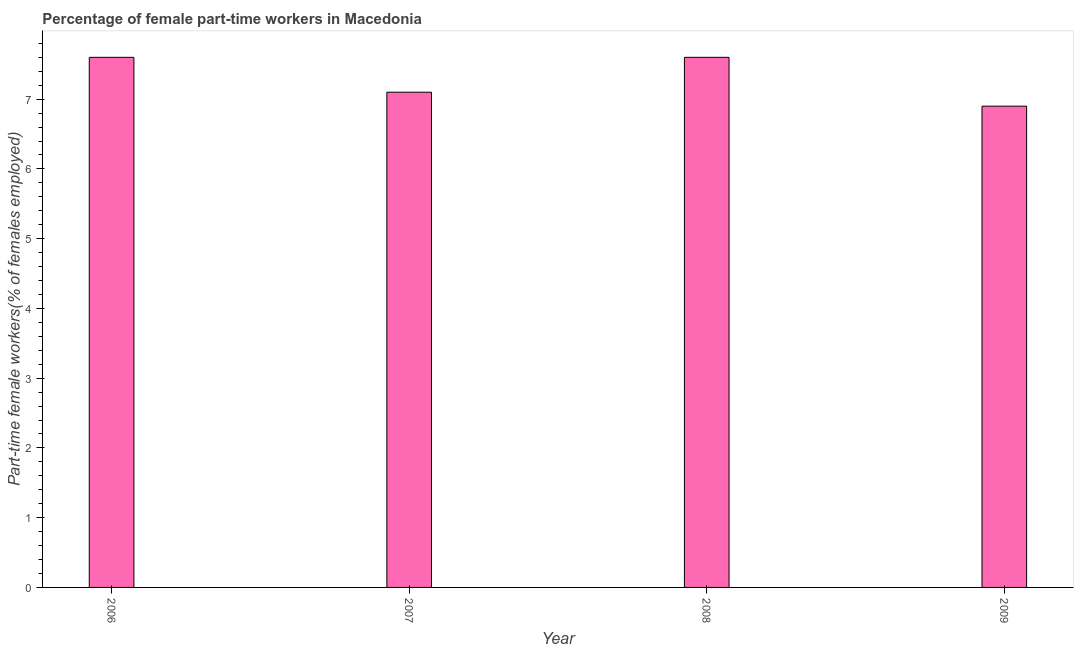Does the graph contain grids?
Your answer should be compact. No. What is the title of the graph?
Give a very brief answer. Percentage of female part-time workers in Macedonia. What is the label or title of the X-axis?
Your response must be concise. Year. What is the label or title of the Y-axis?
Keep it short and to the point. Part-time female workers(% of females employed). What is the percentage of part-time female workers in 2009?
Ensure brevity in your answer.  6.9. Across all years, what is the maximum percentage of part-time female workers?
Your answer should be compact. 7.6. Across all years, what is the minimum percentage of part-time female workers?
Your response must be concise. 6.9. In which year was the percentage of part-time female workers maximum?
Offer a terse response. 2006. What is the sum of the percentage of part-time female workers?
Keep it short and to the point. 29.2. What is the difference between the percentage of part-time female workers in 2007 and 2008?
Ensure brevity in your answer.  -0.5. What is the median percentage of part-time female workers?
Offer a terse response. 7.35. In how many years, is the percentage of part-time female workers greater than 4.6 %?
Provide a short and direct response. 4. What is the ratio of the percentage of part-time female workers in 2006 to that in 2009?
Give a very brief answer. 1.1. Is the percentage of part-time female workers in 2008 less than that in 2009?
Keep it short and to the point. No. Is the difference between the percentage of part-time female workers in 2007 and 2008 greater than the difference between any two years?
Offer a very short reply. No. What is the difference between the highest and the second highest percentage of part-time female workers?
Your response must be concise. 0. Is the sum of the percentage of part-time female workers in 2007 and 2008 greater than the maximum percentage of part-time female workers across all years?
Offer a terse response. Yes. How many bars are there?
Offer a very short reply. 4. How many years are there in the graph?
Your answer should be very brief. 4. What is the Part-time female workers(% of females employed) in 2006?
Your answer should be very brief. 7.6. What is the Part-time female workers(% of females employed) of 2007?
Make the answer very short. 7.1. What is the Part-time female workers(% of females employed) in 2008?
Your response must be concise. 7.6. What is the Part-time female workers(% of females employed) of 2009?
Ensure brevity in your answer.  6.9. What is the difference between the Part-time female workers(% of females employed) in 2006 and 2007?
Your answer should be very brief. 0.5. What is the difference between the Part-time female workers(% of females employed) in 2006 and 2008?
Provide a succinct answer. 0. What is the difference between the Part-time female workers(% of females employed) in 2007 and 2008?
Provide a succinct answer. -0.5. What is the difference between the Part-time female workers(% of females employed) in 2007 and 2009?
Offer a terse response. 0.2. What is the difference between the Part-time female workers(% of females employed) in 2008 and 2009?
Your response must be concise. 0.7. What is the ratio of the Part-time female workers(% of females employed) in 2006 to that in 2007?
Your response must be concise. 1.07. What is the ratio of the Part-time female workers(% of females employed) in 2006 to that in 2009?
Your answer should be compact. 1.1. What is the ratio of the Part-time female workers(% of females employed) in 2007 to that in 2008?
Provide a short and direct response. 0.93. What is the ratio of the Part-time female workers(% of females employed) in 2007 to that in 2009?
Keep it short and to the point. 1.03. What is the ratio of the Part-time female workers(% of females employed) in 2008 to that in 2009?
Your response must be concise. 1.1. 